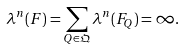<formula> <loc_0><loc_0><loc_500><loc_500>\lambda ^ { n } ( F ) = \sum _ { Q \in \mathfrak Q } \lambda ^ { n } ( F _ { Q } ) = \infty .</formula> 